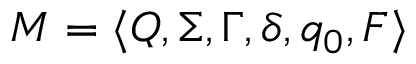<formula> <loc_0><loc_0><loc_500><loc_500>M = \langle Q , \Sigma , \Gamma , \delta , q _ { 0 } , F \rangle</formula> 